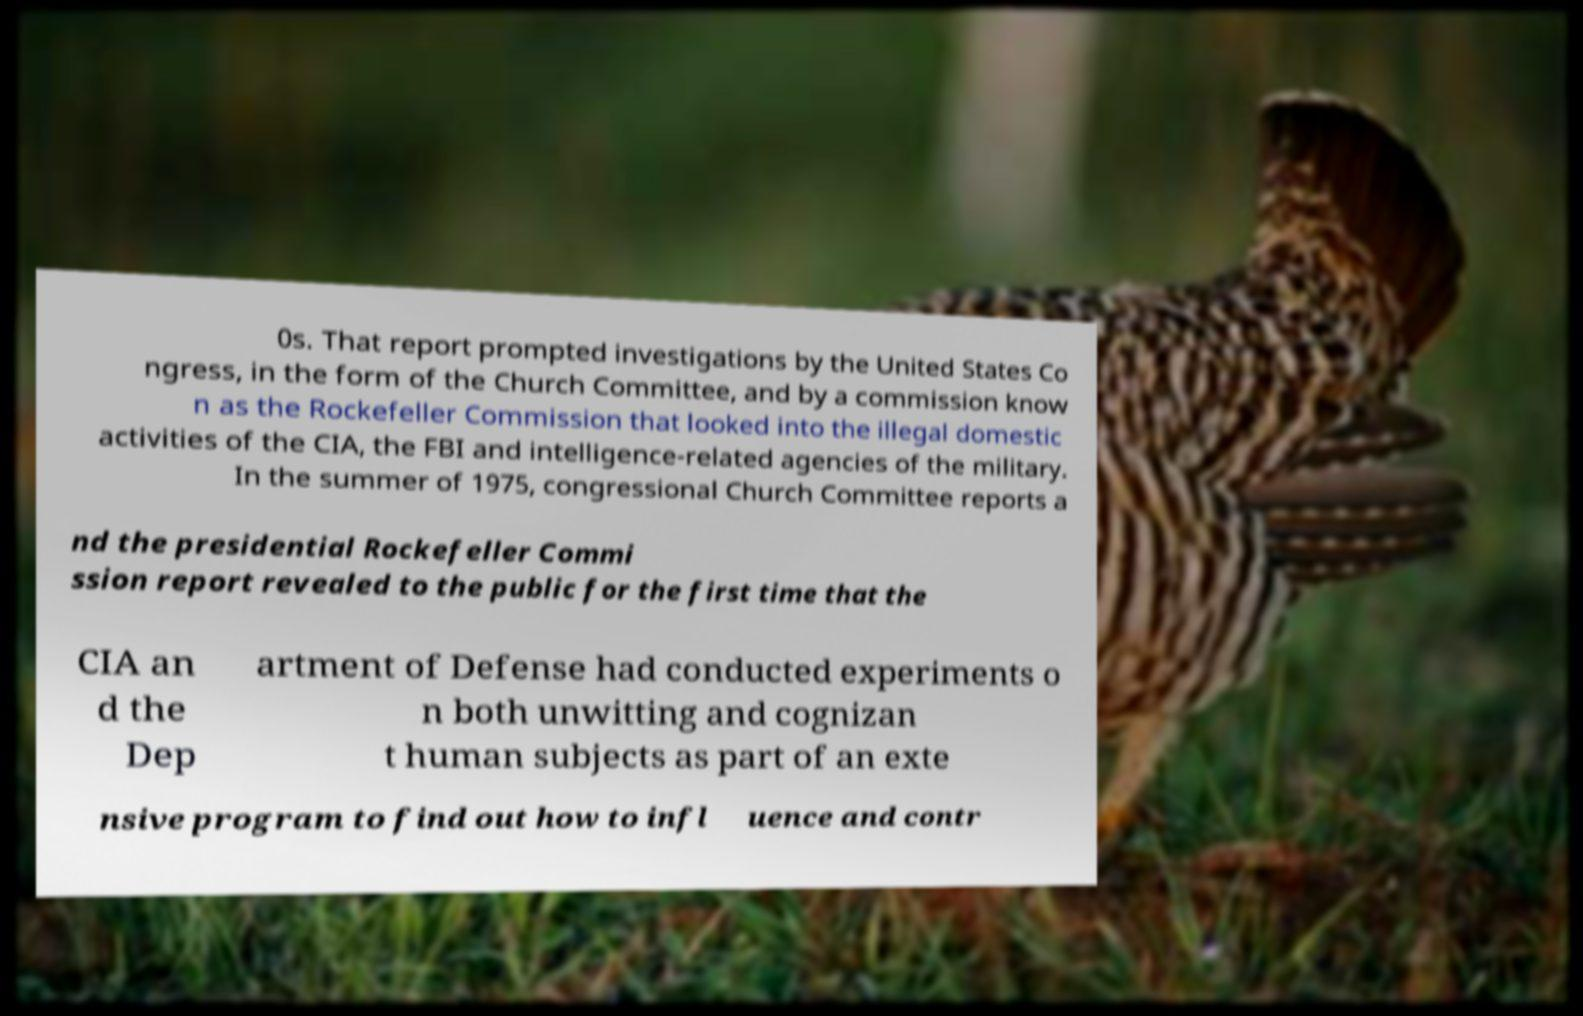Can you read and provide the text displayed in the image?This photo seems to have some interesting text. Can you extract and type it out for me? 0s. That report prompted investigations by the United States Co ngress, in the form of the Church Committee, and by a commission know n as the Rockefeller Commission that looked into the illegal domestic activities of the CIA, the FBI and intelligence-related agencies of the military. In the summer of 1975, congressional Church Committee reports a nd the presidential Rockefeller Commi ssion report revealed to the public for the first time that the CIA an d the Dep artment of Defense had conducted experiments o n both unwitting and cognizan t human subjects as part of an exte nsive program to find out how to infl uence and contr 